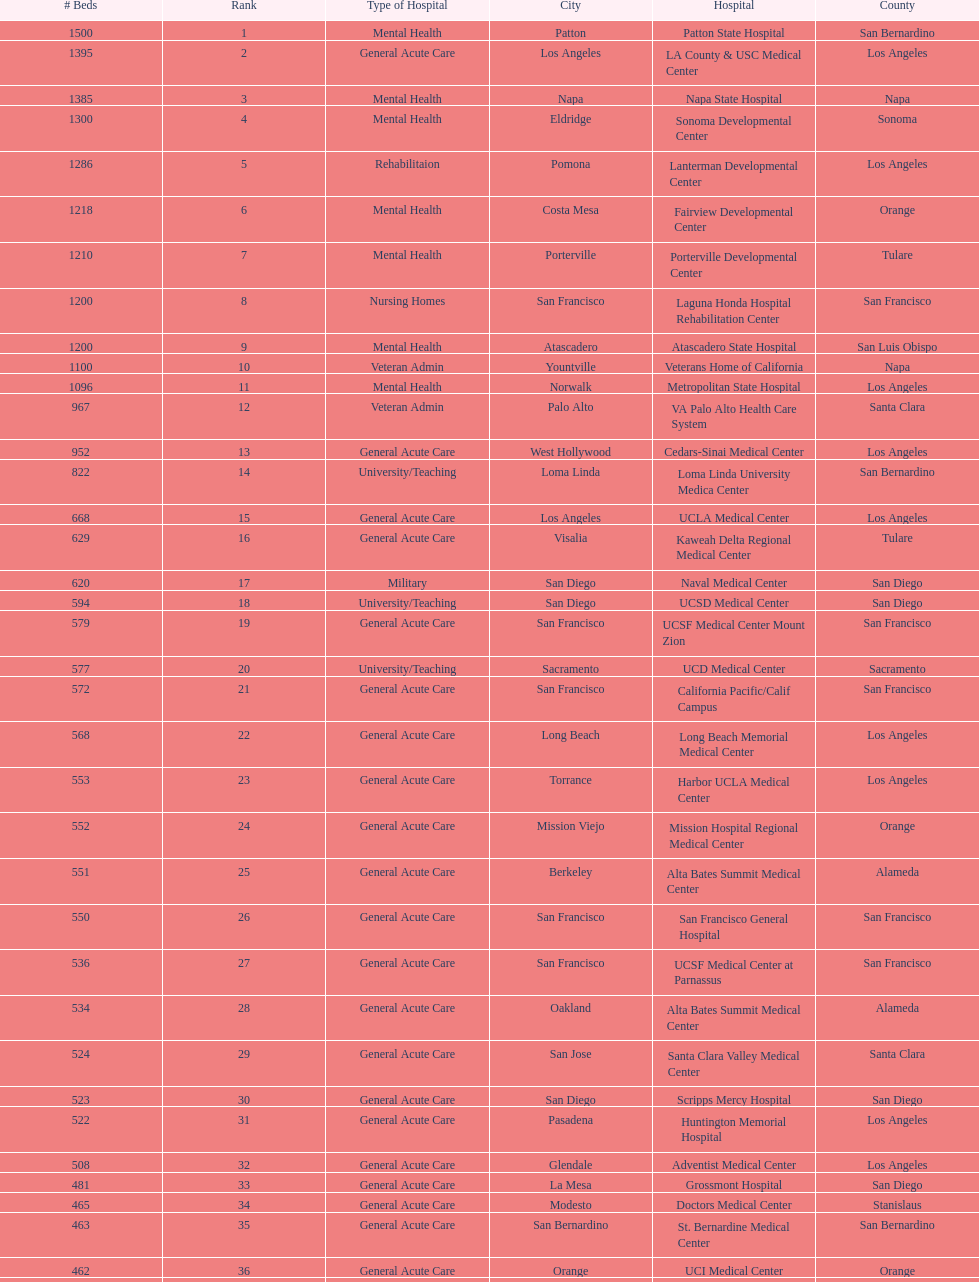What two hospitals holding consecutive rankings of 8 and 9 respectively, both provide 1200 hospital beds? Laguna Honda Hospital Rehabilitation Center, Atascadero State Hospital. 